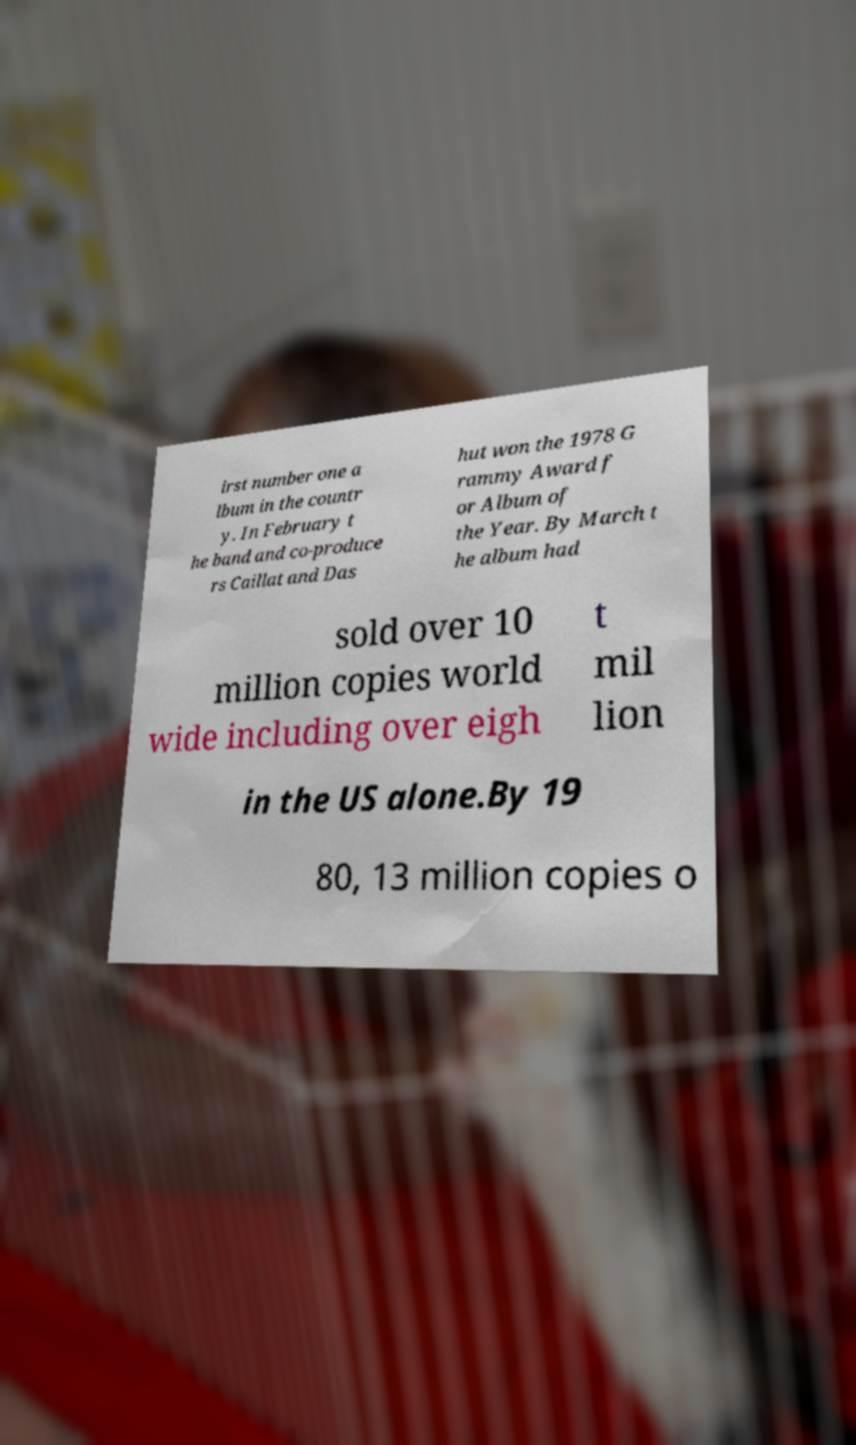Could you extract and type out the text from this image? irst number one a lbum in the countr y. In February t he band and co-produce rs Caillat and Das hut won the 1978 G rammy Award f or Album of the Year. By March t he album had sold over 10 million copies world wide including over eigh t mil lion in the US alone.By 19 80, 13 million copies o 